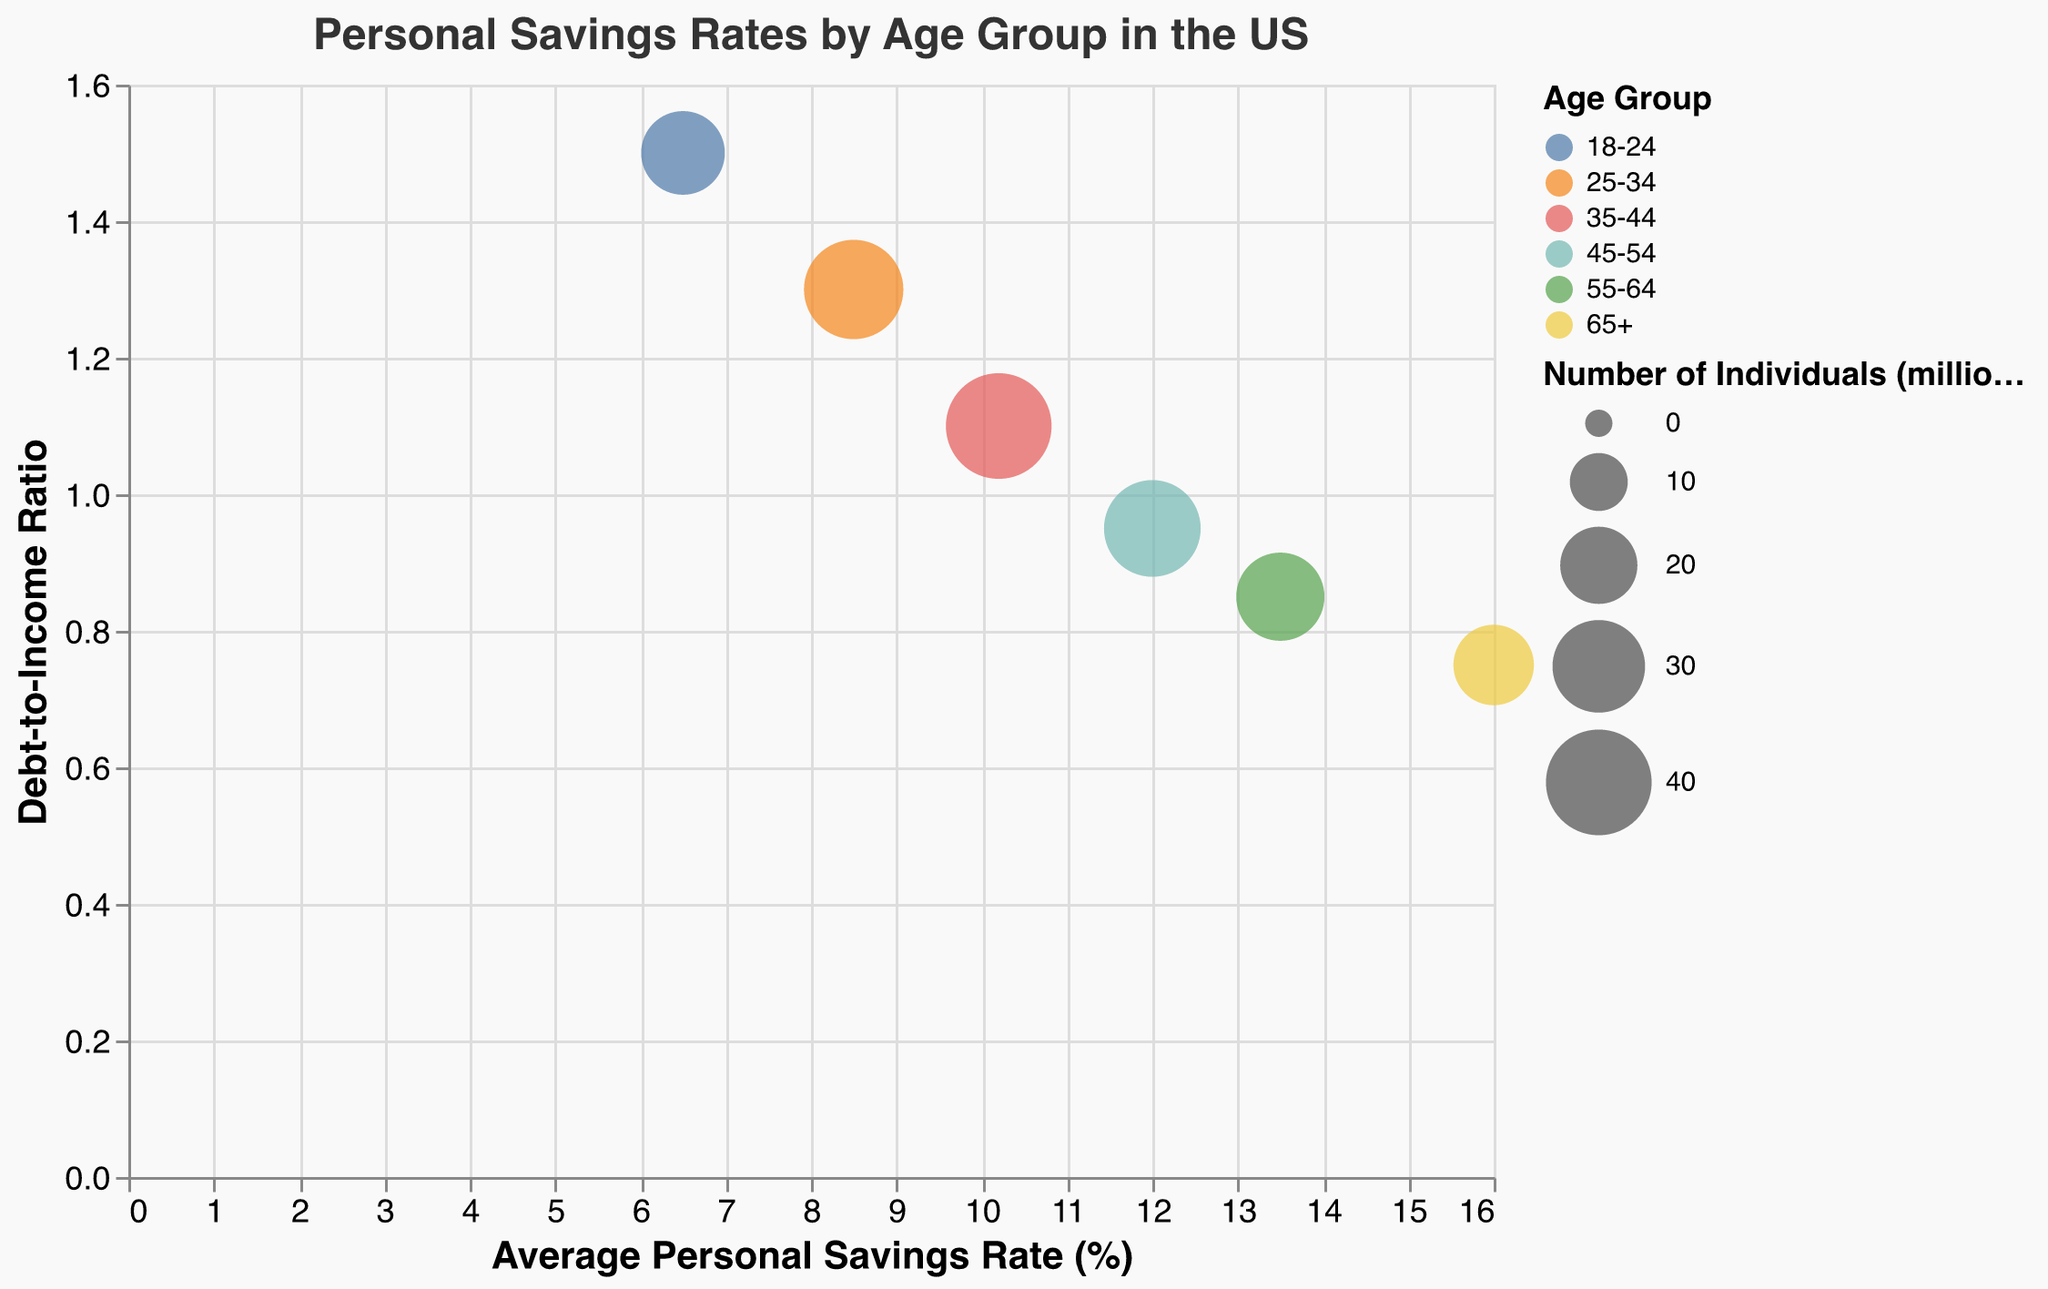What is the average personal savings rate for the 35-44 age group? The chart shows the average personal savings rate as percentages on the X-axis for each age group. The 35-44 age group has a savings rate of 10.2%.
Answer: 10.2% How many individuals are in the 25-34 age group? Number of individuals is represented by the size of the bubbles in millions, indicated in the tooltip as well. The tooltip for the 25-34 age group shows 35 million individuals.
Answer: 35 million Which age group has the highest average personal savings rate? By looking at the X-axis (average personal savings rate) and identifying the furthest bubble to the right, we can see that the 65+ group has the highest savings rate of 16.0%.
Answer: 65+ For the age group 45-54, what is the debt-to-income ratio? The debt-to-income ratio is shown on the Y-axis, and details can be found in the tooltip. The 45-54 age group has a debt-to-income ratio of 0.95.
Answer: 0.95 Which age group has the highest debt-to-income ratio and what is it? To find the highest debt-to-income ratio, we look at the Y-axis and find the topmost bubble. The 18-24 age group has the highest ratio of 1.5.
Answer: 18-24 with 1.5 Compare the personal savings rate of the 18-24 age group to the 55-64 age group. Which has a higher savings rate? By comparing their positions on the X-axis, we see that the 55-64 age group at 13.5% has a higher personal savings rate than the 18-24 age group at 6.5%.
Answer: 55-64 What is the difference in the number of individuals between the 35-44 and 65+ age groups? The 35-44 age group has 40 million individuals, and the 65+ group has 22 million. The difference is 40 - 22 = 18 million.
Answer: 18 million Which age group shows the lowest debt-to-income ratio and what is it? By checking the Y-axis, the lowest point corresponds to the 65+ age group, which has a debt-to-income ratio of 0.75.
Answer: 65+ with 0.75 Are there any age groups with a savings rate above 12%? If so, which ones? Bubbles with an X-axis value greater than 12% indicate savings rates above 12%. Both the 55-64 age group at 13.5% and the 65+ group at 16.0% meet this criterion.
Answer: 55-64 and 65+ What is the average personal savings rate for all age groups combined? The average personal savings rate is the sum of all savings rates divided by the number of age groups: (6.5 + 8.5 + 10.2 + 12.0 + 13.5 + 16.0) / 6 = 66.7 / 6 ≈ 11.12%.
Answer: 11.12% 